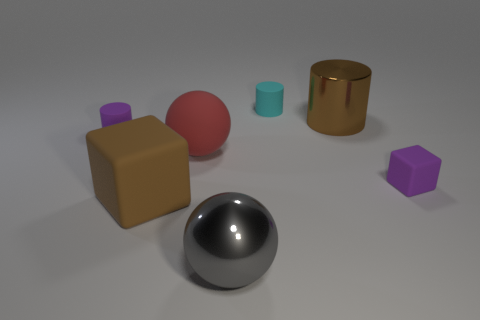Subtract all matte cylinders. How many cylinders are left? 1 Add 2 big metal cylinders. How many objects exist? 9 Subtract all balls. How many objects are left? 5 Subtract 2 cylinders. How many cylinders are left? 1 Subtract all big gray things. Subtract all large gray rubber cylinders. How many objects are left? 6 Add 7 big metallic spheres. How many big metallic spheres are left? 8 Add 1 rubber balls. How many rubber balls exist? 2 Subtract all red balls. How many balls are left? 1 Subtract 1 red balls. How many objects are left? 6 Subtract all blue spheres. Subtract all blue cubes. How many spheres are left? 2 